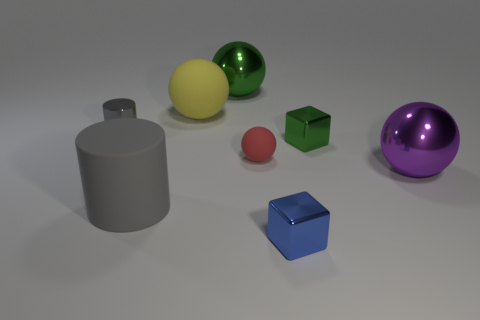Is there any other thing that has the same size as the purple sphere?
Make the answer very short. Yes. Is there any other thing that is the same shape as the small blue shiny thing?
Your answer should be compact. Yes. The small green thing behind the big metal ball that is right of the large metallic sphere that is behind the tiny cylinder is made of what material?
Provide a short and direct response. Metal. Is there a blue rubber object of the same size as the blue metallic thing?
Offer a terse response. No. There is a metal sphere left of the large metal ball that is right of the green ball; what color is it?
Provide a succinct answer. Green. How many green shiny things are there?
Offer a very short reply. 2. Does the tiny ball have the same color as the metallic cylinder?
Keep it short and to the point. No. Are there fewer gray metal cylinders that are in front of the big gray rubber thing than cylinders that are on the right side of the yellow ball?
Your answer should be compact. No. What color is the small ball?
Make the answer very short. Red. How many things have the same color as the big matte cylinder?
Your response must be concise. 1. 